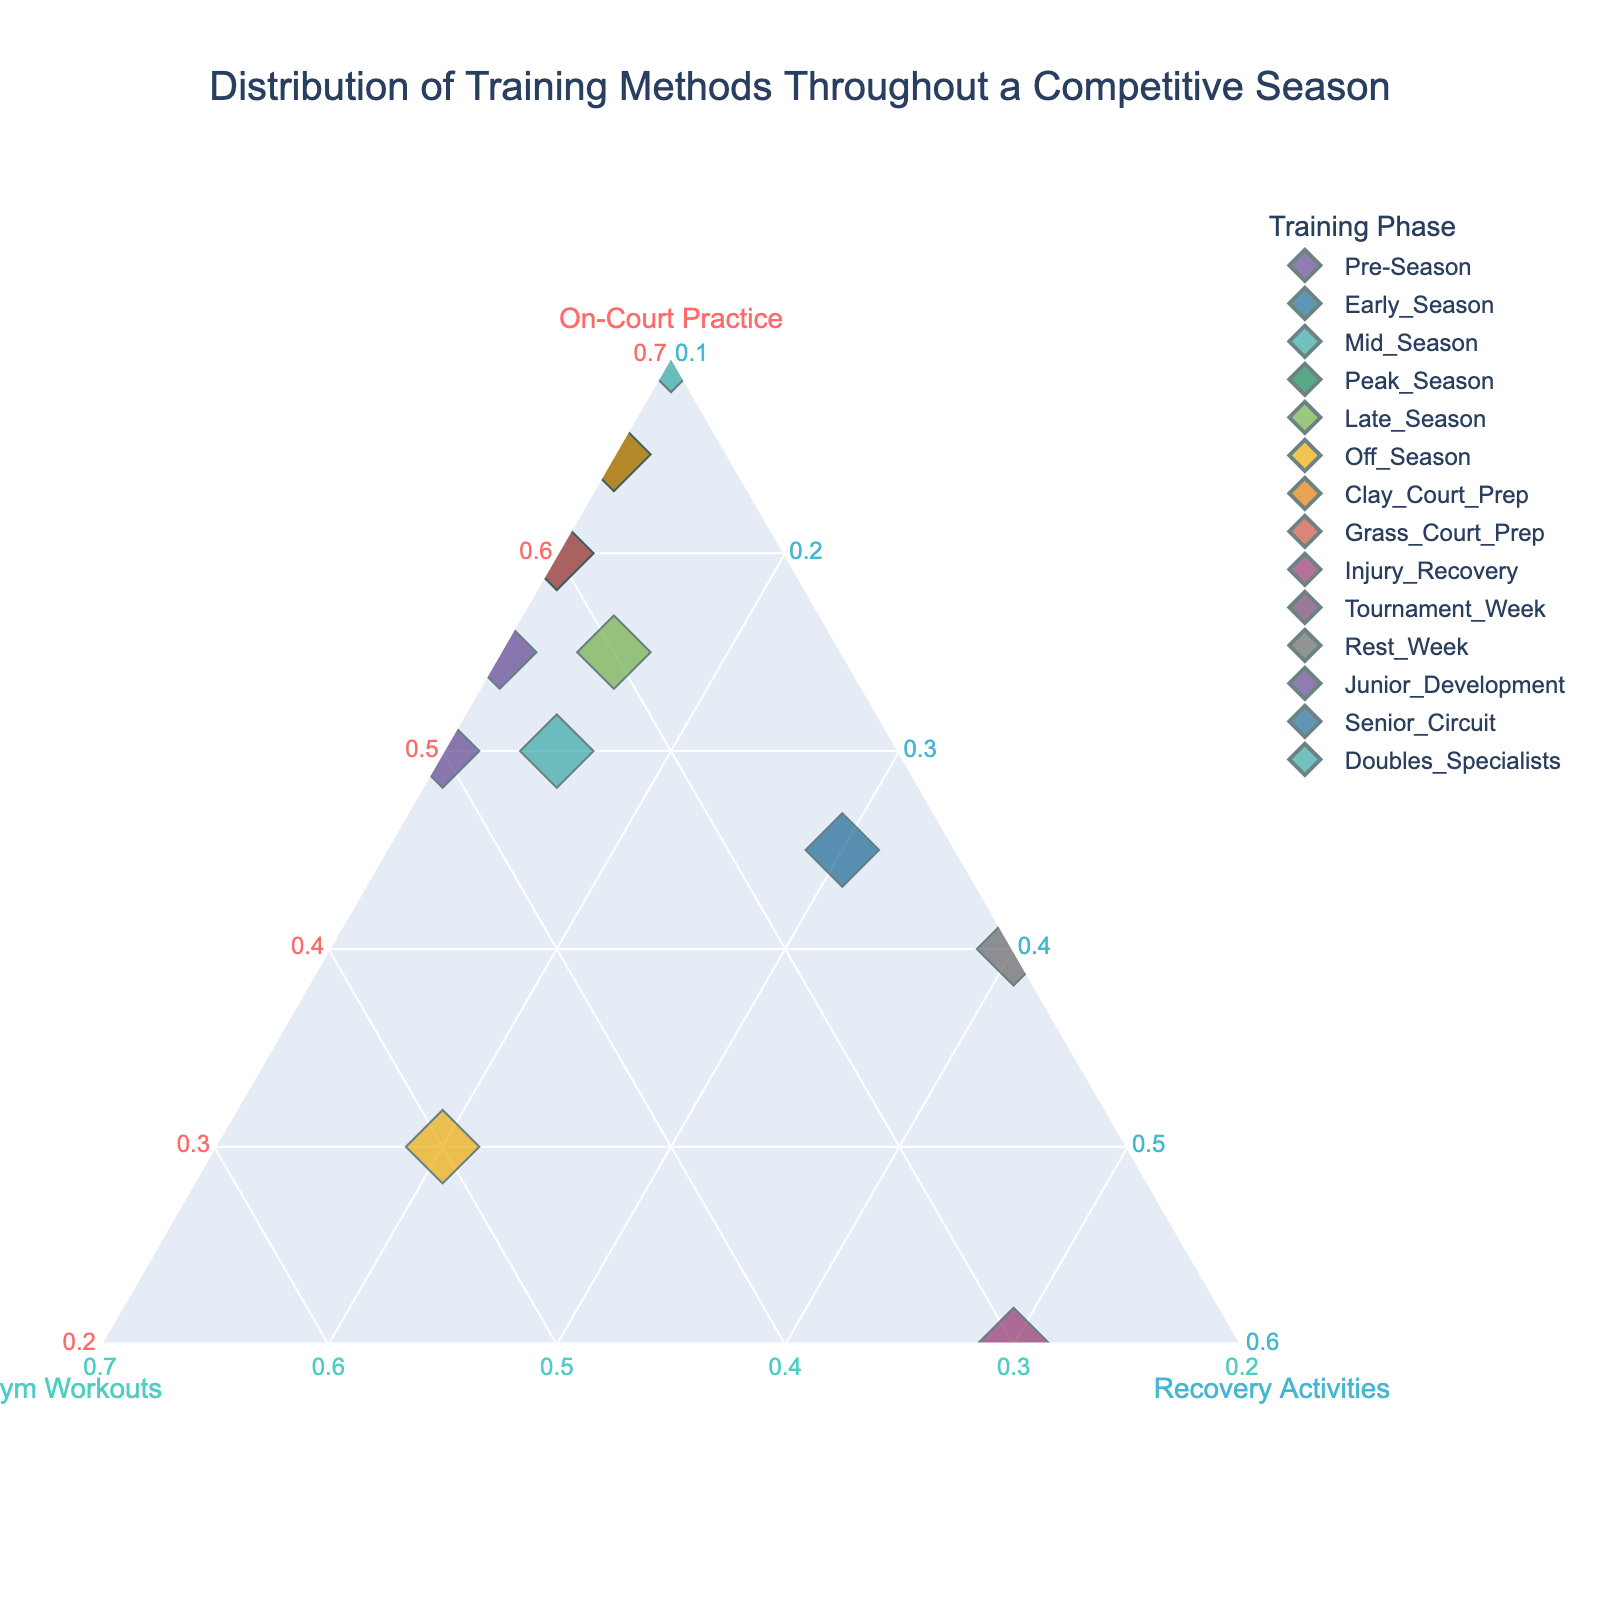What is the title of the ternary plot? The title is usually displayed at the top of the figure. Reading it, we can see the purpose of the plot.
Answer: Distribution of Training Methods Throughout a Competitive Season Which training phase devotes the highest percentage to on-court practice? By examining the points in the ternary plot, identify the one closest to the "On-Court Practice" axis.
Answer: Tournament Week Which training phase shows the highest percentage of recovery activities? Look for the data point closest to the "Recovery Activities" corner of the ternary plot.
Answer: Injury Recovery How does the Late Season phase compare to the Off Season phase in terms of gym workouts? Compare the positions of the Late Season and Off Season points relative to the "Gym Workouts" axis to see which is closer.
Answer: Off Season has a higher percentage of gym workouts What is the average percentage of gym workouts in the Early Season, Mid Season, and Peak Season phases? Locate the points for these phases, note their gym workout percentages (30%, 20%, 25%), sum them (30+20+25=75), and divide by 3 to find the average (75/3).
Answer: 25% Which training phase has an equal distribution between on-court practice (50%) and gym workouts (50%)? Identify the phase that falls equidistantly between the "On-Court Practice" and "Gym Workouts" axes.
Answer: Off Season How does the training distribution for Junior Development differ from Senior Circuit in terms of recovery activities? Compare the positions of Junior Development and Senior Circuit points relative to the "Recovery Activities" axis.
Answer: Senior Circuit has a higher percentage of recovery activities Which training phases have the same percentage of recovery activities? Find the points that align on the same horizontal level relative to the "Recovery Activities" axis.
Answer: Pre-Season, Early Season, Mid Season, Peak Season, Clay Court Prep, Grass Court Prep, Tournament Week, Junior Development all have 10% Among the phases, which one dedicates the least percentage to on-court practice? Look for the data point closest to the "Gym Workouts" and "Recovery Activities" corners, meaning it is farthest from the "On-Court Practice" corner.
Answer: Injury Recovery Which phases show a significant focus on gym workouts (over 30%)? Identify data points that are located primarily along the "Gym Workouts" axis with values exceeding 30%.
Answer: Pre-Season, Off Season, Junior Development, Doubles Specialists, Injury Recovery, Senior Circuit 